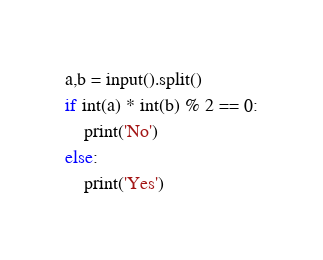Convert code to text. <code><loc_0><loc_0><loc_500><loc_500><_Python_>a,b = input().split()
if int(a) * int(b) % 2 == 0:
    print('No')
else: 
    print('Yes')
</code> 